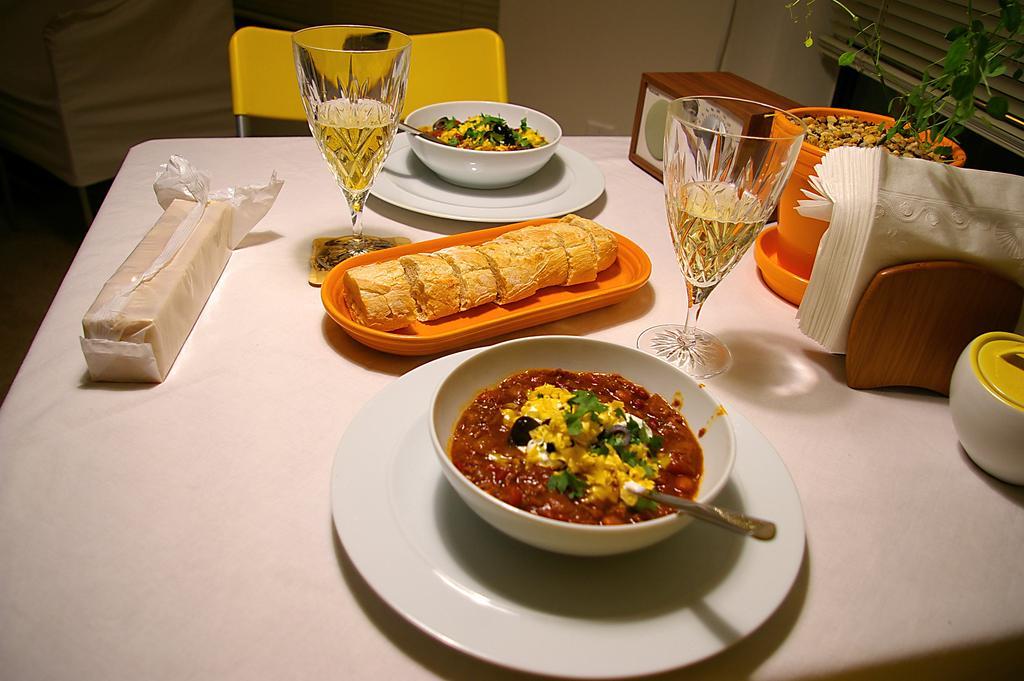Please provide a concise description of this image. In front of the image there is a table. On top of it there is a flower pot. There are glasses, food items in a bowls and a few other objects. Behind the table there are chairs. In the background of the image there is a wall. 